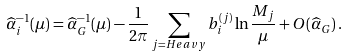<formula> <loc_0><loc_0><loc_500><loc_500>\widehat { \alpha } _ { i } ^ { - 1 } ( \mu ) = \widehat { \alpha } _ { G } ^ { - 1 } ( \mu ) - \frac { 1 } { 2 \pi } \sum _ { j = H e a v y } b ^ { ( j ) } _ { i } \ln \frac { M _ { j } } { \mu } + O ( \widehat { \alpha } _ { G } ) \, .</formula> 